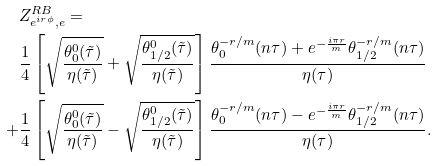Convert formula to latex. <formula><loc_0><loc_0><loc_500><loc_500>& Z _ { e ^ { i r \phi } , e } ^ { R B } = \\ & \frac { 1 } { 4 } \left [ \sqrt { \frac { \theta _ { 0 } ^ { 0 } ( \tilde { \tau } ) } { \eta ( \tilde { \tau } ) } } + \sqrt { \frac { \theta _ { 1 / 2 } ^ { 0 } ( \tilde { \tau } ) } { \eta ( \tilde { \tau } ) } } \right ] \frac { \theta _ { 0 } ^ { - r / m } ( n \tau ) + e ^ { - \frac { i \pi r } { m } } \theta _ { 1 / 2 } ^ { - r / m } ( n \tau ) } { \eta ( \tau ) } \\ + & \frac { 1 } { 4 } \left [ \sqrt { \frac { \theta _ { 0 } ^ { 0 } ( \tilde { \tau } ) } { \eta ( \tilde { \tau } ) } } - \sqrt { \frac { \theta _ { 1 / 2 } ^ { 0 } ( \tilde { \tau } ) } { \eta ( \tilde { \tau } ) } } \right ] \frac { \theta _ { 0 } ^ { - r / m } ( n \tau ) - e ^ { - \frac { i \pi r } { m } } \theta _ { 1 / 2 } ^ { - r / m } ( n \tau ) } { \eta ( \tau ) } .</formula> 